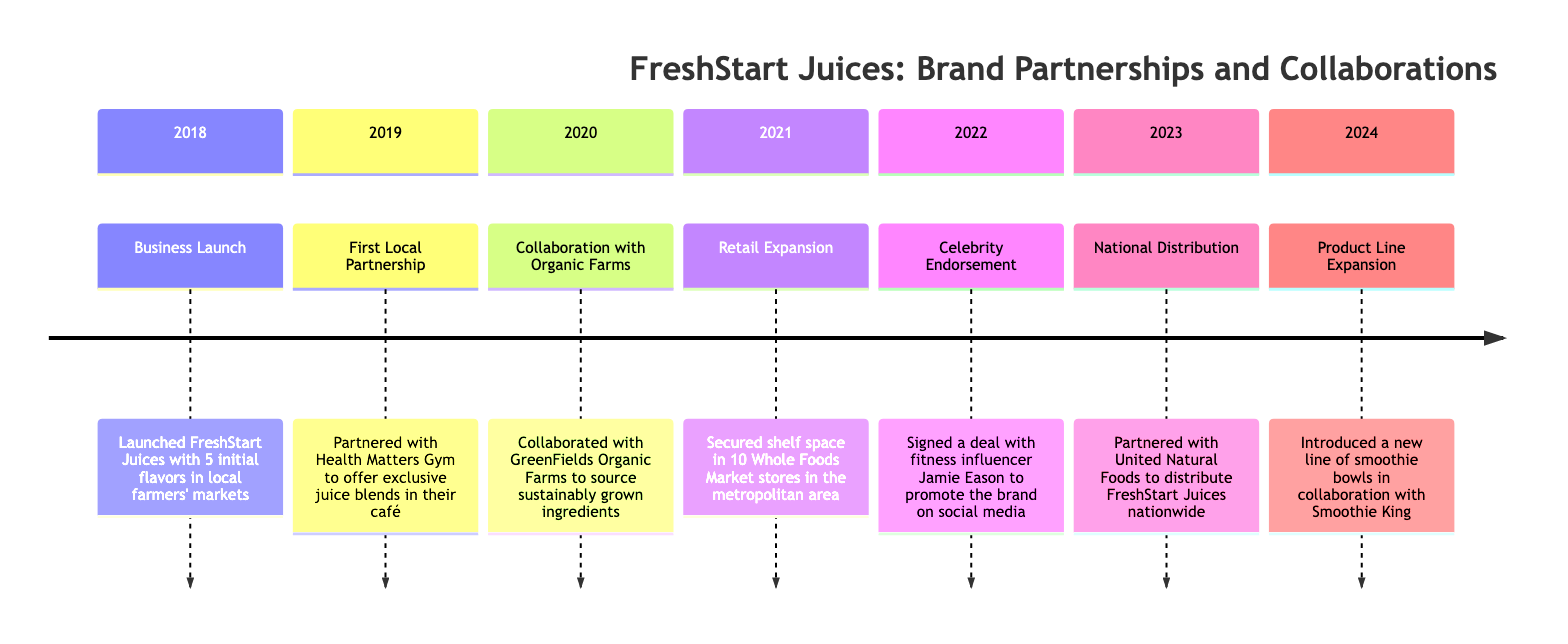What year did the business launch? The diagram indicates that the business, FreshStart Juices, launched in the year 2018, marked by the milestone "Business Launch."
Answer: 2018 What was the first partnership formed? The timeline shows that the first partnership was with Health Matters Gym, labeled as "First Local Partnership," which occurred in 2019.
Answer: Health Matters Gym How many Whole Foods Market stores secured shelf space? According to the timeline, the milestone in 2021 indicates that FreshStart Juices secured shelf space in 10 Whole Foods Market stores.
Answer: 10 In which year did the celebrity endorsement take place? The diagram highlights that the celebrity endorsement occurred in 2022, as noted under the milestone "Celebrity Endorsement."
Answer: 2022 What major distribution partnership was formed in 2023? The timeline specifies that in 2023, FreshStart Juices partnered with United Natural Foods for nationwide distribution, as depicted by the milestone "National Distribution."
Answer: United Natural Foods What was the focus of the collaboration in 2020? The timeline reveals that in 2020, the collaboration was focused on sourcing sustainably grown ingredients, associated with the milestone "Collaboration with Organic Farms."
Answer: Organic Farms How many years passed between the business launch and national distribution? Calculating the time from 2018 (launch) to 2023 (national distribution), we find that 5 years passed between these two milestones.
Answer: 5 years What new product line was introduced in 2024? The timeline specifies that in 2024, FreshStart Juices introduced a new line of smoothie bowls, highlighted by the milestone "Product Line Expansion."
Answer: Smoothie bowls What significant milestone occurred immediately before the retail expansion? As seen in the timeline, the milestone just before "Retail Expansion" (2021) is the "Collaboration with Organic Farms" occurring in 2020, indicating a sequential relationship.
Answer: Collaboration with Organic Farms What unique aspect does the "First Local Partnership" milestone show about regional growth? The "First Local Partnership" with Health Matters Gym in 2019 indicates a focus on local market growth through partnerships, establishing a foundation for future expansion.
Answer: Partnerships 